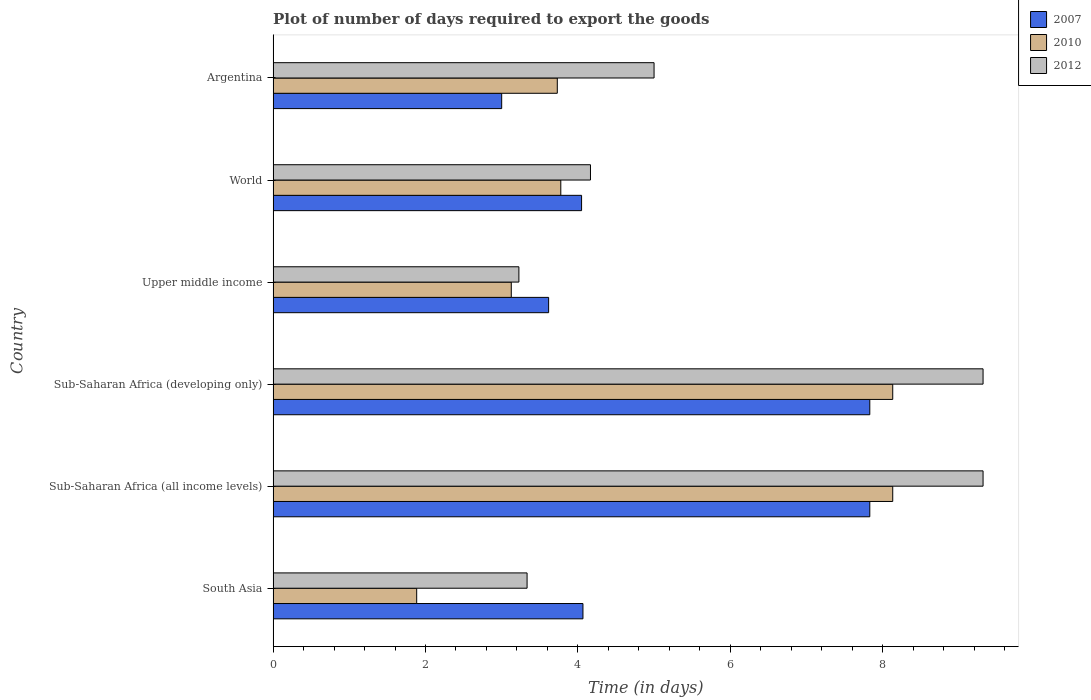How many groups of bars are there?
Offer a terse response. 6. Are the number of bars per tick equal to the number of legend labels?
Provide a short and direct response. Yes. Are the number of bars on each tick of the Y-axis equal?
Your answer should be very brief. Yes. How many bars are there on the 4th tick from the top?
Ensure brevity in your answer.  3. What is the time required to export goods in 2007 in Sub-Saharan Africa (all income levels)?
Offer a terse response. 7.83. Across all countries, what is the maximum time required to export goods in 2007?
Your response must be concise. 7.83. In which country was the time required to export goods in 2012 maximum?
Offer a terse response. Sub-Saharan Africa (all income levels). What is the total time required to export goods in 2007 in the graph?
Provide a short and direct response. 30.39. What is the difference between the time required to export goods in 2012 in Argentina and that in World?
Offer a terse response. 0.83. What is the difference between the time required to export goods in 2012 in Argentina and the time required to export goods in 2007 in Upper middle income?
Provide a succinct answer. 1.38. What is the average time required to export goods in 2010 per country?
Provide a short and direct response. 4.8. What is the difference between the time required to export goods in 2010 and time required to export goods in 2007 in World?
Provide a short and direct response. -0.27. In how many countries, is the time required to export goods in 2007 greater than 7.6 days?
Provide a short and direct response. 2. What is the ratio of the time required to export goods in 2010 in South Asia to that in World?
Provide a succinct answer. 0.5. Is the time required to export goods in 2012 in Upper middle income less than that in World?
Make the answer very short. Yes. What is the difference between the highest and the lowest time required to export goods in 2010?
Provide a succinct answer. 6.25. Is the sum of the time required to export goods in 2007 in Argentina and Sub-Saharan Africa (all income levels) greater than the maximum time required to export goods in 2012 across all countries?
Make the answer very short. Yes. What does the 3rd bar from the top in Sub-Saharan Africa (developing only) represents?
Give a very brief answer. 2007. What does the 2nd bar from the bottom in Sub-Saharan Africa (all income levels) represents?
Give a very brief answer. 2010. How many bars are there?
Your response must be concise. 18. How many countries are there in the graph?
Offer a terse response. 6. What is the difference between two consecutive major ticks on the X-axis?
Provide a succinct answer. 2. Are the values on the major ticks of X-axis written in scientific E-notation?
Your response must be concise. No. Does the graph contain grids?
Your answer should be very brief. No. Where does the legend appear in the graph?
Your answer should be compact. Top right. How are the legend labels stacked?
Offer a terse response. Vertical. What is the title of the graph?
Offer a very short reply. Plot of number of days required to export the goods. Does "1964" appear as one of the legend labels in the graph?
Provide a succinct answer. No. What is the label or title of the X-axis?
Offer a terse response. Time (in days). What is the Time (in days) of 2007 in South Asia?
Offer a very short reply. 4.07. What is the Time (in days) of 2010 in South Asia?
Your answer should be very brief. 1.88. What is the Time (in days) in 2012 in South Asia?
Your answer should be compact. 3.33. What is the Time (in days) of 2007 in Sub-Saharan Africa (all income levels)?
Your answer should be compact. 7.83. What is the Time (in days) of 2010 in Sub-Saharan Africa (all income levels)?
Provide a succinct answer. 8.13. What is the Time (in days) of 2012 in Sub-Saharan Africa (all income levels)?
Ensure brevity in your answer.  9.32. What is the Time (in days) of 2007 in Sub-Saharan Africa (developing only)?
Provide a short and direct response. 7.83. What is the Time (in days) of 2010 in Sub-Saharan Africa (developing only)?
Offer a terse response. 8.13. What is the Time (in days) in 2012 in Sub-Saharan Africa (developing only)?
Make the answer very short. 9.32. What is the Time (in days) of 2007 in Upper middle income?
Ensure brevity in your answer.  3.62. What is the Time (in days) of 2010 in Upper middle income?
Offer a terse response. 3.13. What is the Time (in days) of 2012 in Upper middle income?
Offer a very short reply. 3.23. What is the Time (in days) in 2007 in World?
Offer a terse response. 4.05. What is the Time (in days) in 2010 in World?
Your response must be concise. 3.78. What is the Time (in days) in 2012 in World?
Your answer should be very brief. 4.17. What is the Time (in days) of 2007 in Argentina?
Ensure brevity in your answer.  3. What is the Time (in days) of 2010 in Argentina?
Provide a succinct answer. 3.73. Across all countries, what is the maximum Time (in days) in 2007?
Ensure brevity in your answer.  7.83. Across all countries, what is the maximum Time (in days) in 2010?
Your response must be concise. 8.13. Across all countries, what is the maximum Time (in days) in 2012?
Make the answer very short. 9.32. Across all countries, what is the minimum Time (in days) of 2007?
Your answer should be very brief. 3. Across all countries, what is the minimum Time (in days) in 2010?
Give a very brief answer. 1.88. Across all countries, what is the minimum Time (in days) in 2012?
Make the answer very short. 3.23. What is the total Time (in days) in 2007 in the graph?
Your answer should be very brief. 30.39. What is the total Time (in days) of 2010 in the graph?
Provide a short and direct response. 28.78. What is the total Time (in days) in 2012 in the graph?
Offer a terse response. 34.36. What is the difference between the Time (in days) in 2007 in South Asia and that in Sub-Saharan Africa (all income levels)?
Give a very brief answer. -3.76. What is the difference between the Time (in days) in 2010 in South Asia and that in Sub-Saharan Africa (all income levels)?
Give a very brief answer. -6.25. What is the difference between the Time (in days) of 2012 in South Asia and that in Sub-Saharan Africa (all income levels)?
Your answer should be compact. -5.98. What is the difference between the Time (in days) of 2007 in South Asia and that in Sub-Saharan Africa (developing only)?
Make the answer very short. -3.76. What is the difference between the Time (in days) of 2010 in South Asia and that in Sub-Saharan Africa (developing only)?
Make the answer very short. -6.25. What is the difference between the Time (in days) in 2012 in South Asia and that in Sub-Saharan Africa (developing only)?
Your response must be concise. -5.98. What is the difference between the Time (in days) of 2007 in South Asia and that in Upper middle income?
Your answer should be compact. 0.45. What is the difference between the Time (in days) of 2010 in South Asia and that in Upper middle income?
Offer a very short reply. -1.24. What is the difference between the Time (in days) in 2012 in South Asia and that in Upper middle income?
Keep it short and to the point. 0.11. What is the difference between the Time (in days) in 2007 in South Asia and that in World?
Offer a terse response. 0.02. What is the difference between the Time (in days) of 2010 in South Asia and that in World?
Provide a short and direct response. -1.89. What is the difference between the Time (in days) of 2012 in South Asia and that in World?
Your answer should be very brief. -0.83. What is the difference between the Time (in days) of 2007 in South Asia and that in Argentina?
Offer a terse response. 1.07. What is the difference between the Time (in days) in 2010 in South Asia and that in Argentina?
Keep it short and to the point. -1.85. What is the difference between the Time (in days) in 2012 in South Asia and that in Argentina?
Offer a very short reply. -1.67. What is the difference between the Time (in days) in 2012 in Sub-Saharan Africa (all income levels) and that in Sub-Saharan Africa (developing only)?
Make the answer very short. 0. What is the difference between the Time (in days) of 2007 in Sub-Saharan Africa (all income levels) and that in Upper middle income?
Provide a short and direct response. 4.22. What is the difference between the Time (in days) in 2010 in Sub-Saharan Africa (all income levels) and that in Upper middle income?
Your response must be concise. 5.01. What is the difference between the Time (in days) in 2012 in Sub-Saharan Africa (all income levels) and that in Upper middle income?
Your response must be concise. 6.09. What is the difference between the Time (in days) in 2007 in Sub-Saharan Africa (all income levels) and that in World?
Keep it short and to the point. 3.78. What is the difference between the Time (in days) of 2010 in Sub-Saharan Africa (all income levels) and that in World?
Provide a short and direct response. 4.36. What is the difference between the Time (in days) in 2012 in Sub-Saharan Africa (all income levels) and that in World?
Keep it short and to the point. 5.15. What is the difference between the Time (in days) of 2007 in Sub-Saharan Africa (all income levels) and that in Argentina?
Provide a succinct answer. 4.83. What is the difference between the Time (in days) in 2010 in Sub-Saharan Africa (all income levels) and that in Argentina?
Your response must be concise. 4.4. What is the difference between the Time (in days) in 2012 in Sub-Saharan Africa (all income levels) and that in Argentina?
Your response must be concise. 4.32. What is the difference between the Time (in days) of 2007 in Sub-Saharan Africa (developing only) and that in Upper middle income?
Offer a very short reply. 4.22. What is the difference between the Time (in days) of 2010 in Sub-Saharan Africa (developing only) and that in Upper middle income?
Give a very brief answer. 5.01. What is the difference between the Time (in days) in 2012 in Sub-Saharan Africa (developing only) and that in Upper middle income?
Ensure brevity in your answer.  6.09. What is the difference between the Time (in days) in 2007 in Sub-Saharan Africa (developing only) and that in World?
Make the answer very short. 3.78. What is the difference between the Time (in days) in 2010 in Sub-Saharan Africa (developing only) and that in World?
Give a very brief answer. 4.36. What is the difference between the Time (in days) in 2012 in Sub-Saharan Africa (developing only) and that in World?
Provide a short and direct response. 5.15. What is the difference between the Time (in days) in 2007 in Sub-Saharan Africa (developing only) and that in Argentina?
Your answer should be very brief. 4.83. What is the difference between the Time (in days) of 2010 in Sub-Saharan Africa (developing only) and that in Argentina?
Your answer should be very brief. 4.4. What is the difference between the Time (in days) of 2012 in Sub-Saharan Africa (developing only) and that in Argentina?
Your response must be concise. 4.32. What is the difference between the Time (in days) in 2007 in Upper middle income and that in World?
Your answer should be compact. -0.43. What is the difference between the Time (in days) in 2010 in Upper middle income and that in World?
Offer a very short reply. -0.65. What is the difference between the Time (in days) of 2012 in Upper middle income and that in World?
Ensure brevity in your answer.  -0.94. What is the difference between the Time (in days) in 2007 in Upper middle income and that in Argentina?
Offer a very short reply. 0.62. What is the difference between the Time (in days) of 2010 in Upper middle income and that in Argentina?
Give a very brief answer. -0.6. What is the difference between the Time (in days) of 2012 in Upper middle income and that in Argentina?
Provide a short and direct response. -1.77. What is the difference between the Time (in days) of 2007 in World and that in Argentina?
Ensure brevity in your answer.  1.05. What is the difference between the Time (in days) in 2010 in World and that in Argentina?
Your answer should be very brief. 0.05. What is the difference between the Time (in days) of 2012 in World and that in Argentina?
Make the answer very short. -0.83. What is the difference between the Time (in days) of 2007 in South Asia and the Time (in days) of 2010 in Sub-Saharan Africa (all income levels)?
Ensure brevity in your answer.  -4.07. What is the difference between the Time (in days) in 2007 in South Asia and the Time (in days) in 2012 in Sub-Saharan Africa (all income levels)?
Make the answer very short. -5.25. What is the difference between the Time (in days) in 2010 in South Asia and the Time (in days) in 2012 in Sub-Saharan Africa (all income levels)?
Your answer should be very brief. -7.43. What is the difference between the Time (in days) of 2007 in South Asia and the Time (in days) of 2010 in Sub-Saharan Africa (developing only)?
Ensure brevity in your answer.  -4.07. What is the difference between the Time (in days) of 2007 in South Asia and the Time (in days) of 2012 in Sub-Saharan Africa (developing only)?
Your answer should be compact. -5.25. What is the difference between the Time (in days) in 2010 in South Asia and the Time (in days) in 2012 in Sub-Saharan Africa (developing only)?
Offer a terse response. -7.43. What is the difference between the Time (in days) of 2007 in South Asia and the Time (in days) of 2010 in Upper middle income?
Provide a succinct answer. 0.94. What is the difference between the Time (in days) in 2007 in South Asia and the Time (in days) in 2012 in Upper middle income?
Keep it short and to the point. 0.84. What is the difference between the Time (in days) of 2010 in South Asia and the Time (in days) of 2012 in Upper middle income?
Provide a short and direct response. -1.34. What is the difference between the Time (in days) of 2007 in South Asia and the Time (in days) of 2010 in World?
Offer a terse response. 0.29. What is the difference between the Time (in days) of 2007 in South Asia and the Time (in days) of 2012 in World?
Ensure brevity in your answer.  -0.1. What is the difference between the Time (in days) in 2010 in South Asia and the Time (in days) in 2012 in World?
Provide a short and direct response. -2.28. What is the difference between the Time (in days) in 2007 in South Asia and the Time (in days) in 2010 in Argentina?
Keep it short and to the point. 0.34. What is the difference between the Time (in days) in 2007 in South Asia and the Time (in days) in 2012 in Argentina?
Ensure brevity in your answer.  -0.93. What is the difference between the Time (in days) in 2010 in South Asia and the Time (in days) in 2012 in Argentina?
Offer a terse response. -3.12. What is the difference between the Time (in days) of 2007 in Sub-Saharan Africa (all income levels) and the Time (in days) of 2010 in Sub-Saharan Africa (developing only)?
Give a very brief answer. -0.3. What is the difference between the Time (in days) in 2007 in Sub-Saharan Africa (all income levels) and the Time (in days) in 2012 in Sub-Saharan Africa (developing only)?
Ensure brevity in your answer.  -1.49. What is the difference between the Time (in days) in 2010 in Sub-Saharan Africa (all income levels) and the Time (in days) in 2012 in Sub-Saharan Africa (developing only)?
Offer a very short reply. -1.19. What is the difference between the Time (in days) of 2007 in Sub-Saharan Africa (all income levels) and the Time (in days) of 2010 in Upper middle income?
Your answer should be very brief. 4.71. What is the difference between the Time (in days) of 2007 in Sub-Saharan Africa (all income levels) and the Time (in days) of 2012 in Upper middle income?
Your answer should be compact. 4.61. What is the difference between the Time (in days) in 2010 in Sub-Saharan Africa (all income levels) and the Time (in days) in 2012 in Upper middle income?
Keep it short and to the point. 4.91. What is the difference between the Time (in days) of 2007 in Sub-Saharan Africa (all income levels) and the Time (in days) of 2010 in World?
Offer a very short reply. 4.06. What is the difference between the Time (in days) of 2007 in Sub-Saharan Africa (all income levels) and the Time (in days) of 2012 in World?
Provide a short and direct response. 3.67. What is the difference between the Time (in days) in 2010 in Sub-Saharan Africa (all income levels) and the Time (in days) in 2012 in World?
Ensure brevity in your answer.  3.97. What is the difference between the Time (in days) of 2007 in Sub-Saharan Africa (all income levels) and the Time (in days) of 2010 in Argentina?
Give a very brief answer. 4.1. What is the difference between the Time (in days) of 2007 in Sub-Saharan Africa (all income levels) and the Time (in days) of 2012 in Argentina?
Provide a succinct answer. 2.83. What is the difference between the Time (in days) in 2010 in Sub-Saharan Africa (all income levels) and the Time (in days) in 2012 in Argentina?
Your answer should be very brief. 3.13. What is the difference between the Time (in days) in 2007 in Sub-Saharan Africa (developing only) and the Time (in days) in 2010 in Upper middle income?
Offer a terse response. 4.71. What is the difference between the Time (in days) of 2007 in Sub-Saharan Africa (developing only) and the Time (in days) of 2012 in Upper middle income?
Your answer should be compact. 4.61. What is the difference between the Time (in days) in 2010 in Sub-Saharan Africa (developing only) and the Time (in days) in 2012 in Upper middle income?
Your response must be concise. 4.91. What is the difference between the Time (in days) of 2007 in Sub-Saharan Africa (developing only) and the Time (in days) of 2010 in World?
Offer a terse response. 4.06. What is the difference between the Time (in days) in 2007 in Sub-Saharan Africa (developing only) and the Time (in days) in 2012 in World?
Give a very brief answer. 3.67. What is the difference between the Time (in days) of 2010 in Sub-Saharan Africa (developing only) and the Time (in days) of 2012 in World?
Your answer should be compact. 3.97. What is the difference between the Time (in days) in 2007 in Sub-Saharan Africa (developing only) and the Time (in days) in 2010 in Argentina?
Your answer should be very brief. 4.1. What is the difference between the Time (in days) in 2007 in Sub-Saharan Africa (developing only) and the Time (in days) in 2012 in Argentina?
Your answer should be compact. 2.83. What is the difference between the Time (in days) in 2010 in Sub-Saharan Africa (developing only) and the Time (in days) in 2012 in Argentina?
Provide a succinct answer. 3.13. What is the difference between the Time (in days) in 2007 in Upper middle income and the Time (in days) in 2010 in World?
Provide a succinct answer. -0.16. What is the difference between the Time (in days) of 2007 in Upper middle income and the Time (in days) of 2012 in World?
Your answer should be compact. -0.55. What is the difference between the Time (in days) in 2010 in Upper middle income and the Time (in days) in 2012 in World?
Offer a terse response. -1.04. What is the difference between the Time (in days) of 2007 in Upper middle income and the Time (in days) of 2010 in Argentina?
Provide a short and direct response. -0.11. What is the difference between the Time (in days) of 2007 in Upper middle income and the Time (in days) of 2012 in Argentina?
Your answer should be compact. -1.38. What is the difference between the Time (in days) of 2010 in Upper middle income and the Time (in days) of 2012 in Argentina?
Provide a succinct answer. -1.87. What is the difference between the Time (in days) of 2007 in World and the Time (in days) of 2010 in Argentina?
Your response must be concise. 0.32. What is the difference between the Time (in days) of 2007 in World and the Time (in days) of 2012 in Argentina?
Your response must be concise. -0.95. What is the difference between the Time (in days) in 2010 in World and the Time (in days) in 2012 in Argentina?
Make the answer very short. -1.22. What is the average Time (in days) in 2007 per country?
Provide a short and direct response. 5.07. What is the average Time (in days) of 2010 per country?
Make the answer very short. 4.8. What is the average Time (in days) of 2012 per country?
Keep it short and to the point. 5.73. What is the difference between the Time (in days) in 2007 and Time (in days) in 2010 in South Asia?
Offer a very short reply. 2.18. What is the difference between the Time (in days) of 2007 and Time (in days) of 2012 in South Asia?
Provide a short and direct response. 0.73. What is the difference between the Time (in days) of 2010 and Time (in days) of 2012 in South Asia?
Offer a very short reply. -1.45. What is the difference between the Time (in days) of 2007 and Time (in days) of 2010 in Sub-Saharan Africa (all income levels)?
Keep it short and to the point. -0.3. What is the difference between the Time (in days) of 2007 and Time (in days) of 2012 in Sub-Saharan Africa (all income levels)?
Provide a succinct answer. -1.49. What is the difference between the Time (in days) of 2010 and Time (in days) of 2012 in Sub-Saharan Africa (all income levels)?
Give a very brief answer. -1.19. What is the difference between the Time (in days) in 2007 and Time (in days) in 2010 in Sub-Saharan Africa (developing only)?
Your answer should be very brief. -0.3. What is the difference between the Time (in days) of 2007 and Time (in days) of 2012 in Sub-Saharan Africa (developing only)?
Offer a very short reply. -1.49. What is the difference between the Time (in days) in 2010 and Time (in days) in 2012 in Sub-Saharan Africa (developing only)?
Make the answer very short. -1.19. What is the difference between the Time (in days) in 2007 and Time (in days) in 2010 in Upper middle income?
Give a very brief answer. 0.49. What is the difference between the Time (in days) in 2007 and Time (in days) in 2012 in Upper middle income?
Your answer should be compact. 0.39. What is the difference between the Time (in days) in 2010 and Time (in days) in 2012 in Upper middle income?
Ensure brevity in your answer.  -0.1. What is the difference between the Time (in days) in 2007 and Time (in days) in 2010 in World?
Keep it short and to the point. 0.27. What is the difference between the Time (in days) in 2007 and Time (in days) in 2012 in World?
Provide a short and direct response. -0.12. What is the difference between the Time (in days) of 2010 and Time (in days) of 2012 in World?
Provide a succinct answer. -0.39. What is the difference between the Time (in days) of 2007 and Time (in days) of 2010 in Argentina?
Make the answer very short. -0.73. What is the difference between the Time (in days) in 2007 and Time (in days) in 2012 in Argentina?
Offer a terse response. -2. What is the difference between the Time (in days) in 2010 and Time (in days) in 2012 in Argentina?
Your answer should be compact. -1.27. What is the ratio of the Time (in days) of 2007 in South Asia to that in Sub-Saharan Africa (all income levels)?
Ensure brevity in your answer.  0.52. What is the ratio of the Time (in days) of 2010 in South Asia to that in Sub-Saharan Africa (all income levels)?
Your response must be concise. 0.23. What is the ratio of the Time (in days) of 2012 in South Asia to that in Sub-Saharan Africa (all income levels)?
Provide a succinct answer. 0.36. What is the ratio of the Time (in days) in 2007 in South Asia to that in Sub-Saharan Africa (developing only)?
Ensure brevity in your answer.  0.52. What is the ratio of the Time (in days) of 2010 in South Asia to that in Sub-Saharan Africa (developing only)?
Your response must be concise. 0.23. What is the ratio of the Time (in days) in 2012 in South Asia to that in Sub-Saharan Africa (developing only)?
Your answer should be compact. 0.36. What is the ratio of the Time (in days) of 2007 in South Asia to that in Upper middle income?
Make the answer very short. 1.12. What is the ratio of the Time (in days) of 2010 in South Asia to that in Upper middle income?
Your answer should be compact. 0.6. What is the ratio of the Time (in days) of 2012 in South Asia to that in Upper middle income?
Your answer should be very brief. 1.03. What is the ratio of the Time (in days) in 2010 in South Asia to that in World?
Ensure brevity in your answer.  0.5. What is the ratio of the Time (in days) of 2012 in South Asia to that in World?
Your answer should be very brief. 0.8. What is the ratio of the Time (in days) in 2007 in South Asia to that in Argentina?
Ensure brevity in your answer.  1.36. What is the ratio of the Time (in days) of 2010 in South Asia to that in Argentina?
Give a very brief answer. 0.51. What is the ratio of the Time (in days) of 2012 in Sub-Saharan Africa (all income levels) to that in Sub-Saharan Africa (developing only)?
Ensure brevity in your answer.  1. What is the ratio of the Time (in days) of 2007 in Sub-Saharan Africa (all income levels) to that in Upper middle income?
Keep it short and to the point. 2.17. What is the ratio of the Time (in days) of 2010 in Sub-Saharan Africa (all income levels) to that in Upper middle income?
Offer a terse response. 2.6. What is the ratio of the Time (in days) of 2012 in Sub-Saharan Africa (all income levels) to that in Upper middle income?
Offer a very short reply. 2.89. What is the ratio of the Time (in days) of 2007 in Sub-Saharan Africa (all income levels) to that in World?
Your response must be concise. 1.93. What is the ratio of the Time (in days) of 2010 in Sub-Saharan Africa (all income levels) to that in World?
Your answer should be very brief. 2.15. What is the ratio of the Time (in days) of 2012 in Sub-Saharan Africa (all income levels) to that in World?
Ensure brevity in your answer.  2.24. What is the ratio of the Time (in days) in 2007 in Sub-Saharan Africa (all income levels) to that in Argentina?
Provide a succinct answer. 2.61. What is the ratio of the Time (in days) in 2010 in Sub-Saharan Africa (all income levels) to that in Argentina?
Provide a succinct answer. 2.18. What is the ratio of the Time (in days) in 2012 in Sub-Saharan Africa (all income levels) to that in Argentina?
Make the answer very short. 1.86. What is the ratio of the Time (in days) of 2007 in Sub-Saharan Africa (developing only) to that in Upper middle income?
Provide a succinct answer. 2.17. What is the ratio of the Time (in days) in 2010 in Sub-Saharan Africa (developing only) to that in Upper middle income?
Provide a succinct answer. 2.6. What is the ratio of the Time (in days) of 2012 in Sub-Saharan Africa (developing only) to that in Upper middle income?
Give a very brief answer. 2.89. What is the ratio of the Time (in days) in 2007 in Sub-Saharan Africa (developing only) to that in World?
Ensure brevity in your answer.  1.93. What is the ratio of the Time (in days) in 2010 in Sub-Saharan Africa (developing only) to that in World?
Keep it short and to the point. 2.15. What is the ratio of the Time (in days) of 2012 in Sub-Saharan Africa (developing only) to that in World?
Offer a very short reply. 2.24. What is the ratio of the Time (in days) of 2007 in Sub-Saharan Africa (developing only) to that in Argentina?
Ensure brevity in your answer.  2.61. What is the ratio of the Time (in days) of 2010 in Sub-Saharan Africa (developing only) to that in Argentina?
Offer a terse response. 2.18. What is the ratio of the Time (in days) of 2012 in Sub-Saharan Africa (developing only) to that in Argentina?
Offer a terse response. 1.86. What is the ratio of the Time (in days) in 2007 in Upper middle income to that in World?
Ensure brevity in your answer.  0.89. What is the ratio of the Time (in days) of 2010 in Upper middle income to that in World?
Provide a short and direct response. 0.83. What is the ratio of the Time (in days) in 2012 in Upper middle income to that in World?
Keep it short and to the point. 0.77. What is the ratio of the Time (in days) in 2007 in Upper middle income to that in Argentina?
Ensure brevity in your answer.  1.21. What is the ratio of the Time (in days) of 2010 in Upper middle income to that in Argentina?
Offer a terse response. 0.84. What is the ratio of the Time (in days) of 2012 in Upper middle income to that in Argentina?
Your answer should be compact. 0.65. What is the ratio of the Time (in days) of 2007 in World to that in Argentina?
Make the answer very short. 1.35. What is the ratio of the Time (in days) of 2010 in World to that in Argentina?
Offer a terse response. 1.01. What is the ratio of the Time (in days) in 2012 in World to that in Argentina?
Ensure brevity in your answer.  0.83. What is the difference between the highest and the second highest Time (in days) in 2010?
Your answer should be very brief. 0. What is the difference between the highest and the lowest Time (in days) in 2007?
Offer a terse response. 4.83. What is the difference between the highest and the lowest Time (in days) of 2010?
Ensure brevity in your answer.  6.25. What is the difference between the highest and the lowest Time (in days) of 2012?
Provide a short and direct response. 6.09. 